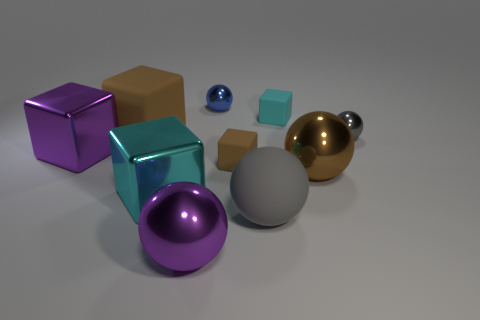Subtract all big rubber blocks. How many blocks are left? 4 Subtract all brown balls. How many balls are left? 4 Subtract 2 cubes. How many cubes are left? 3 Subtract all red spheres. How many purple blocks are left? 1 Add 6 tiny blue objects. How many tiny blue objects are left? 7 Add 2 big cyan metal cubes. How many big cyan metal cubes exist? 3 Subtract 0 cyan spheres. How many objects are left? 10 Subtract all purple balls. Subtract all brown cylinders. How many balls are left? 4 Subtract all big purple metallic spheres. Subtract all cylinders. How many objects are left? 9 